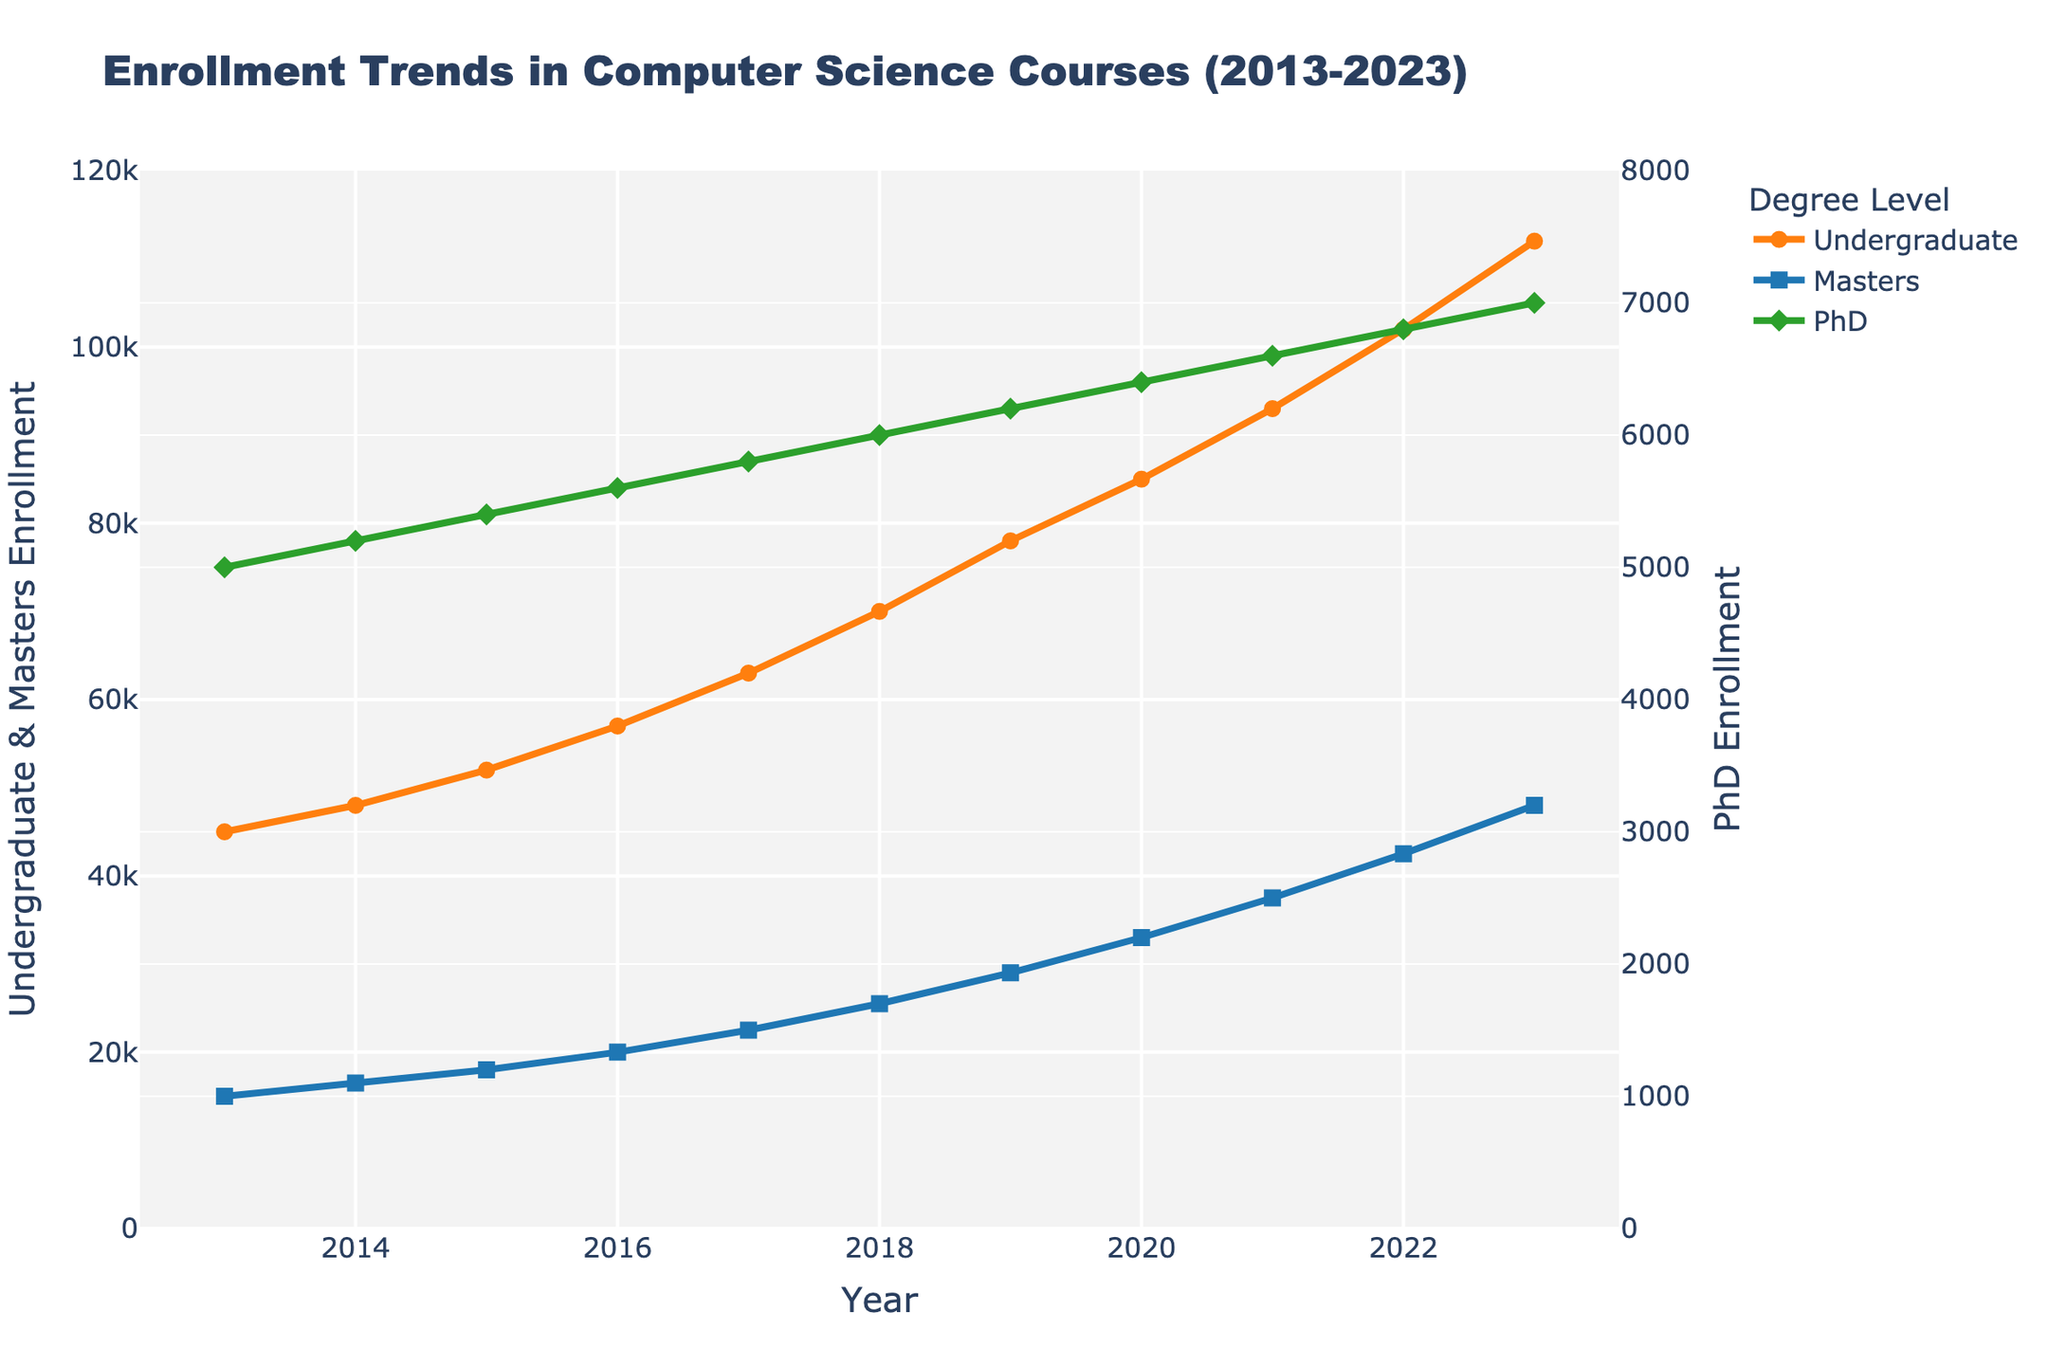What is the overall trend in undergraduate enrollment from 2013 to 2023? The enrollment has a clear upward trend over this period. Starting from 45,000 in 2013, it continues to increase every year, reaching 112,000 in 2023.
Answer: Upward trend In what year did Masters enrollment reach 30,000? Masters enrollment reached 30,000 in the year 2019. This can be seen where the Masters line crosses the 30,000 mark on the y-axis.
Answer: 2019 By how much did PhD enrollment increase from 2013 to 2023? PhD enrollment in 2013 was 5,000 and in 2023 it was 7,000. So, the increase is calculated by subtracting 5,000 from 7,000.
Answer: 2,000 Compare the undergraduate enrollment in 2016 with that in 2018. By how much did it increase? In 2016, undergraduate enrollment was 57,000; in 2018, it was 70,000. The increase is calculated by subtracting 57,000 from 70,000.
Answer: 13,000 Which degree level had the highest enrollment increase over the decade? Undergraduate enrollment increased from 45,000 to 112,000 which is an increase of 67,000. Masters increased from 15,000 to 48,000 which is an increase of 33,000. PhD increased from 5,000 to 7,000 which is an increase of 2,000. The highest increase is in the undergraduate enrollment.
Answer: Undergraduate What is the average annual growth rate of Masters enrollment from 2013 to 2023? First, find the increase in Masters enrollment from 2013 (15,000) to 2023 (48,000), which is 33,000. Then divide this by the number of years (10) to find the average annual growth rate.
Answer: 3,300 per year In which year was the gap between undergraduate and PhD enrollments the largest? The largest gap appears in 2023, where undergraduate enrollment is 112,000 and PhD enrollment is 7,000. The gap is calculated by 112,000 - 7,000 = 105,000.
Answer: 2023 How does the visual representation of the PhD enrollment trend compare to that of undergraduate enrollment? The PhD line is much lower and relatively flatter compared to the steep upward trend of the undergraduate line, indicating that undergrad enrollments grew much faster.
Answer: Flatter and lower What is the total enrollment for all degree levels in the year 2022? The total enrollment is the sum of undergraduate, Masters, and PhD enrollments in 2022, which are 102,000 + 42,500 + 6,800.
Answer: 151,300 